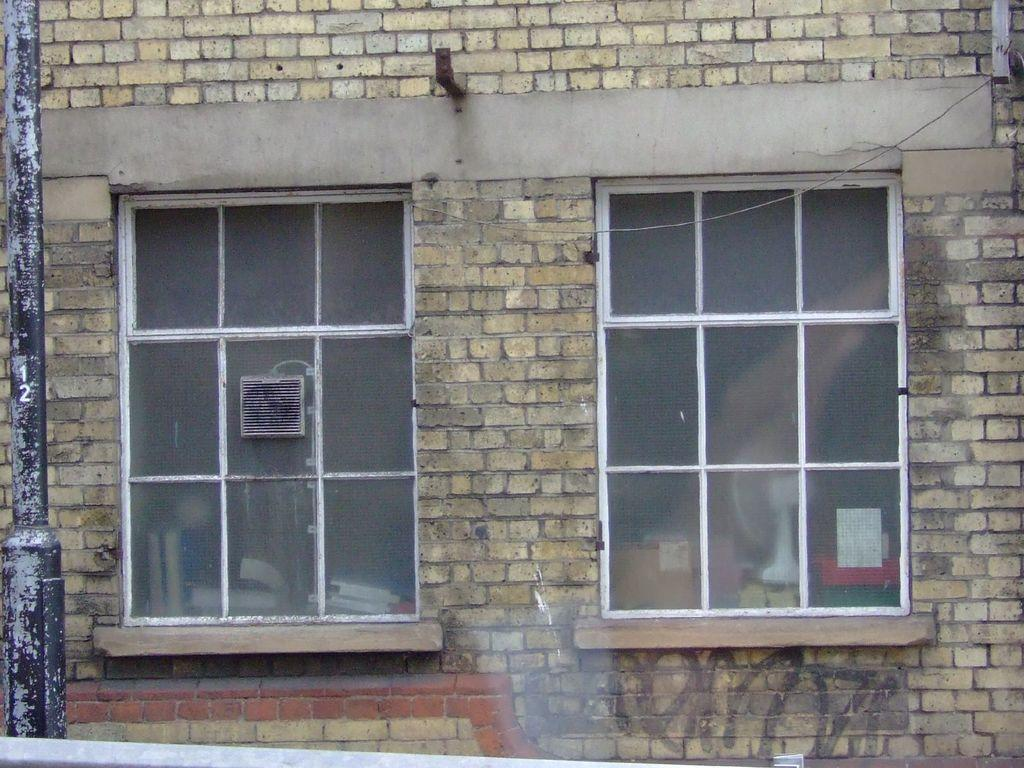What type of structure is visible in the image? There is a brick wall in the image. What feature is present on the brick wall? There are glass windows on the brick wall. What can be seen through the windows? There are objects visible behind the windows. What is located on the left side of the image? There is a pole on the left side of the image. How many frogs are sitting on the station in the image? There are no frogs or stations present in the image. What is the rate of the train passing by the brick wall in the image? There is no train or rate mentioned in the image; it only features a brick wall, windows, and a pole. 